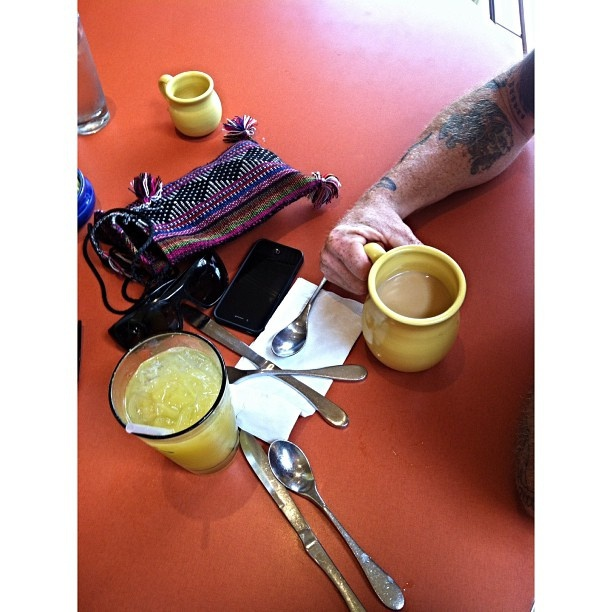Describe the objects in this image and their specific colors. I can see dining table in white, brown, maroon, and black tones, people in white, gray, black, maroon, and brown tones, handbag in white, black, purple, and gray tones, cup in white, tan, khaki, and olive tones, and cup in white, tan, olive, and maroon tones in this image. 